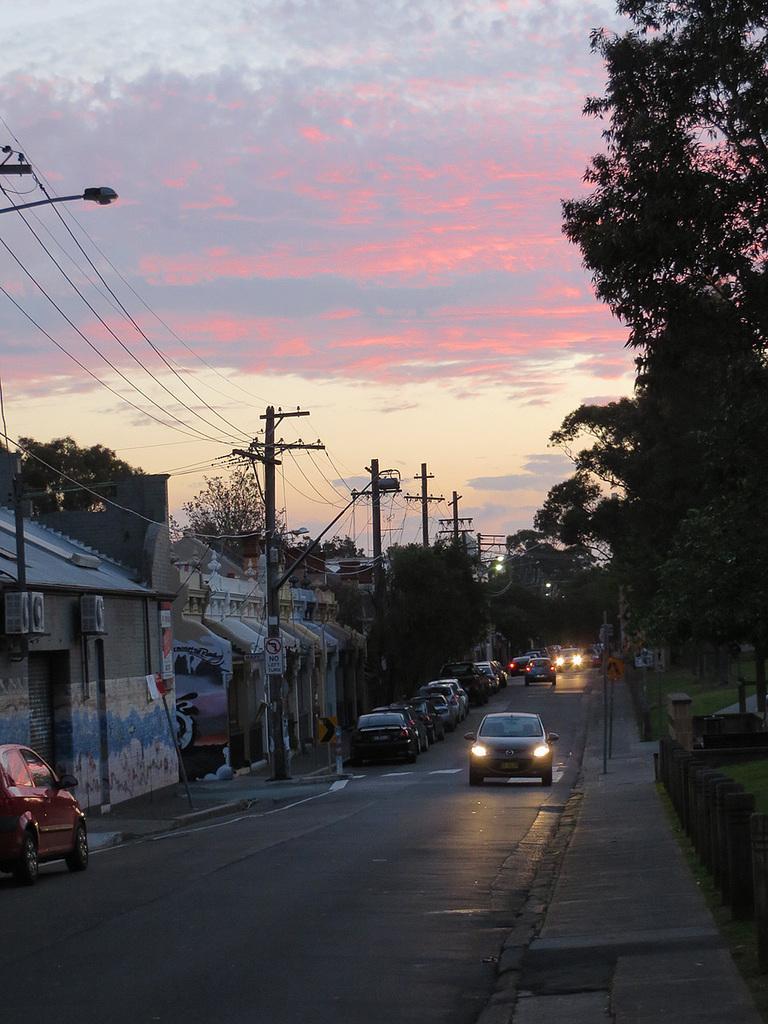Describe this image in one or two sentences. In this image we can see some cars on the road. We can also see utility poles with wires, buildings, trees, poles on the footpath, grass and the sky which looks cloudy. 